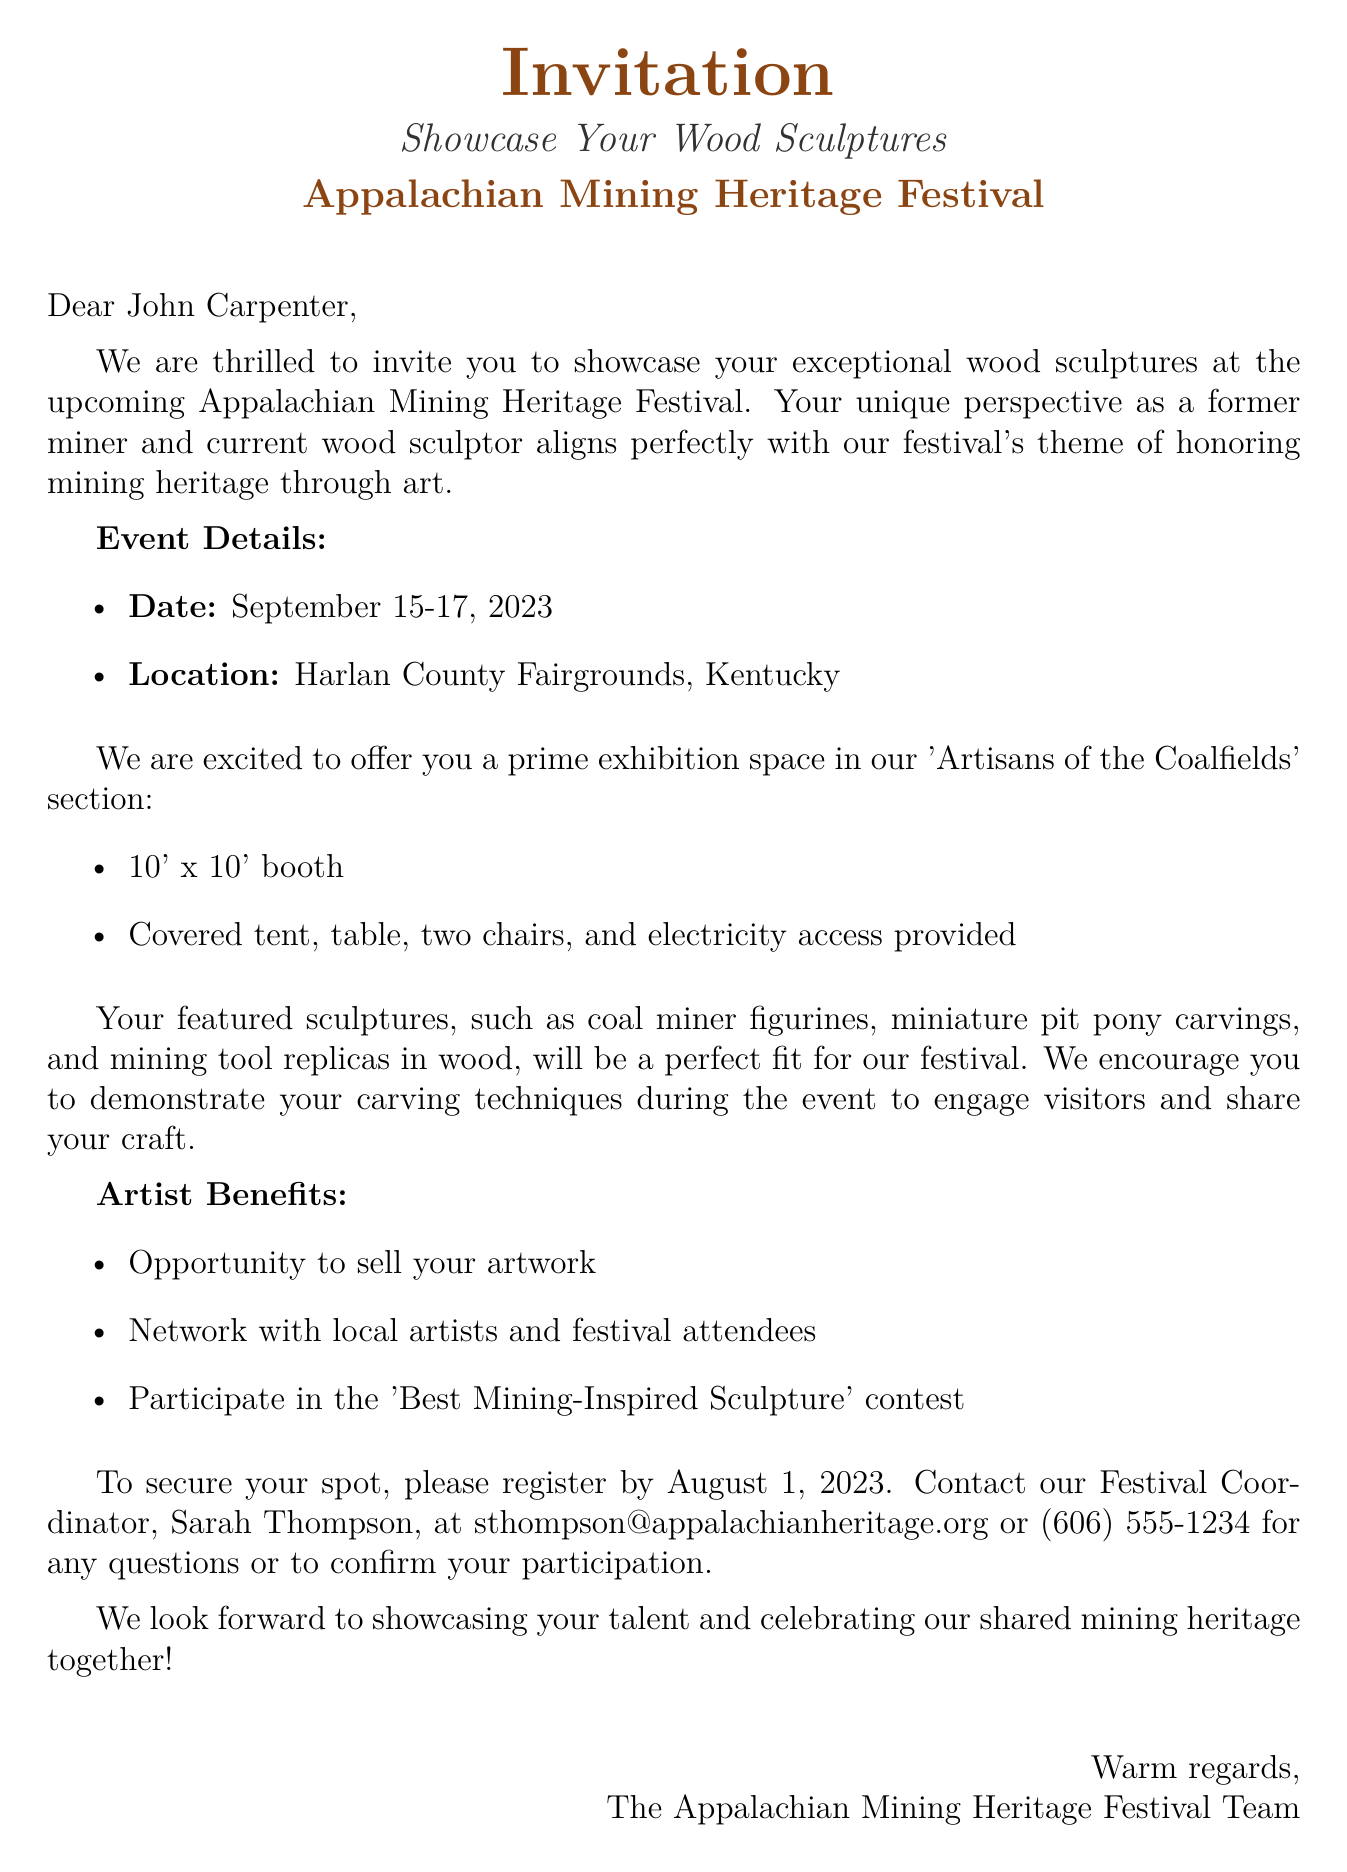What is the date of the festival? The festival is scheduled to take place from September 15 to September 17, 2023.
Answer: September 15-17, 2023 Where will the festival be held? The festival will take place at the Harlan County Fairgrounds in Kentucky.
Answer: Harlan County Fairgrounds, Kentucky What type of booth will be provided? The booth provided is described as a 10' x 10' booth with specific amenities.
Answer: 10' x 10' booth Who is the contact person for registration? The contact person for registration is mentioned as the Festival Coordinator.
Answer: Sarah Thompson What is one of the featured sculptures? The document lists specific types of sculptures that will be featured at the festival.
Answer: Coal miner figurines What is the purpose of the festival? The festival aims to honor mining heritage through art, connecting the background of participants with the event's theme.
Answer: Honoring mining heritage through art What is a benefit of participating in the festival? Participating artists have the opportunity to engage with other artists and attendees during the event.
Answer: Opportunity to sell artwork What is the registration deadline? The document specifies a date by which registration must be completed to participate in the festival.
Answer: August 1, 2023 What is encouraged during the festival? The invitation expresses that artists are encouraged to engage visitors and demonstrate their craft during the event.
Answer: Demonstrate carving techniques 